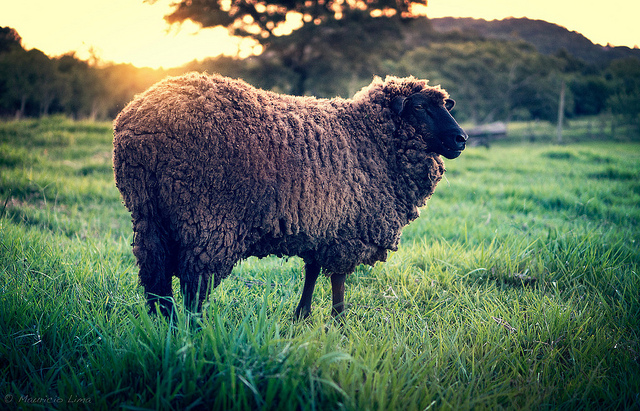Where is the sheep located? The sheep is located in the center of the image, standing in a grassy field. It appears to be surrounded by a vast open space, with some trees and gently rolling hills visible in the background. 